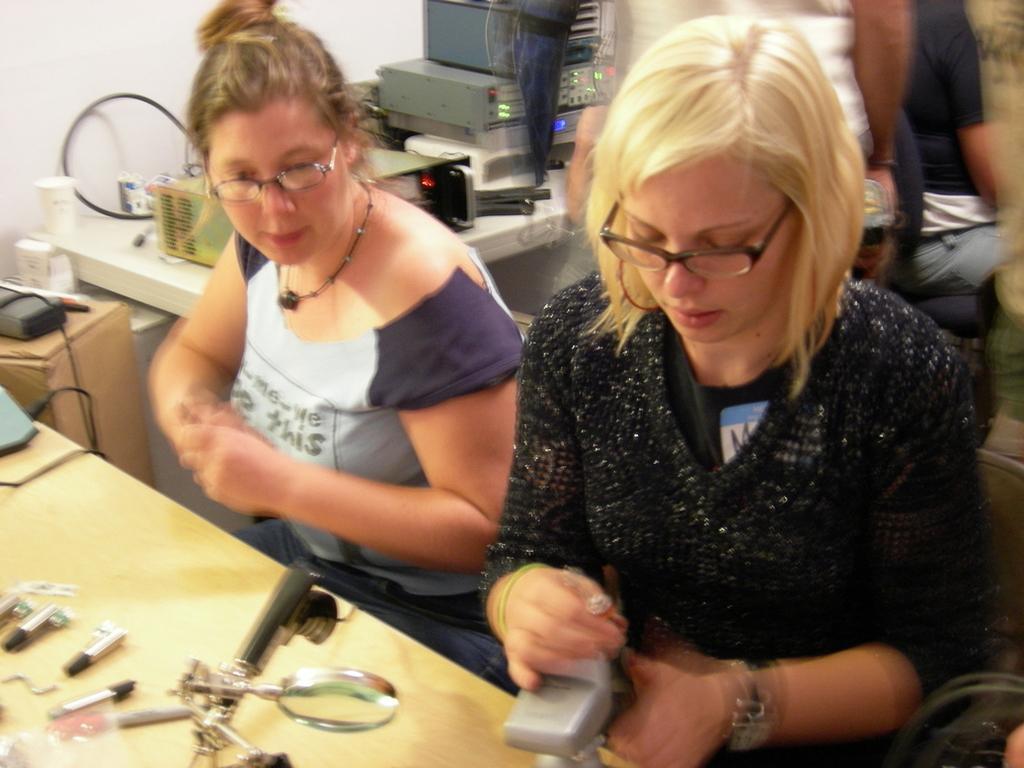Could you give a brief overview of what you see in this image? In this image there are two ladies sitting on chairs, in front of them there is a table, on that table there are few objects, in the background there are people standing and there is a table, on that table there are electrical devices. 